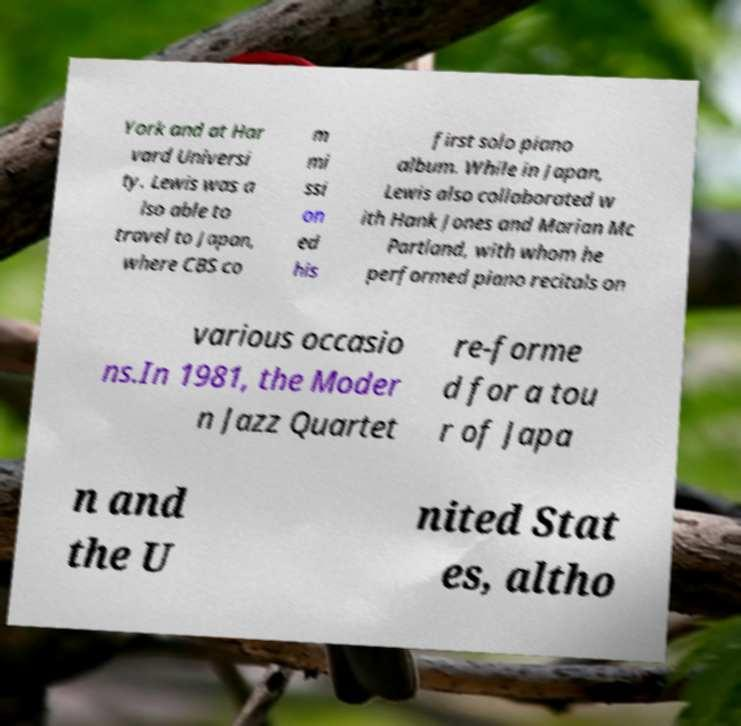I need the written content from this picture converted into text. Can you do that? York and at Har vard Universi ty. Lewis was a lso able to travel to Japan, where CBS co m mi ssi on ed his first solo piano album. While in Japan, Lewis also collaborated w ith Hank Jones and Marian Mc Partland, with whom he performed piano recitals on various occasio ns.In 1981, the Moder n Jazz Quartet re-forme d for a tou r of Japa n and the U nited Stat es, altho 